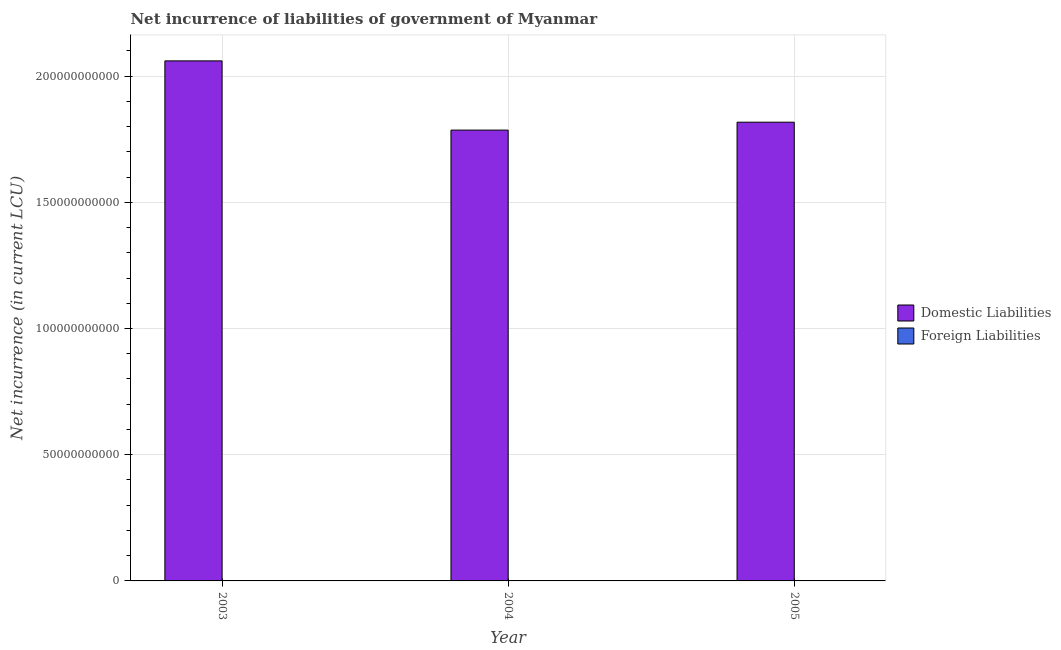Are the number of bars per tick equal to the number of legend labels?
Give a very brief answer. No. How many bars are there on the 2nd tick from the left?
Offer a terse response. 1. How many bars are there on the 1st tick from the right?
Offer a terse response. 1. What is the label of the 3rd group of bars from the left?
Your response must be concise. 2005. What is the net incurrence of domestic liabilities in 2004?
Offer a terse response. 1.79e+11. Across all years, what is the maximum net incurrence of domestic liabilities?
Keep it short and to the point. 2.06e+11. Across all years, what is the minimum net incurrence of foreign liabilities?
Ensure brevity in your answer.  0. In which year was the net incurrence of domestic liabilities maximum?
Your response must be concise. 2003. What is the total net incurrence of domestic liabilities in the graph?
Offer a terse response. 5.66e+11. What is the difference between the net incurrence of domestic liabilities in 2003 and that in 2005?
Give a very brief answer. 2.43e+1. What is the difference between the net incurrence of domestic liabilities in 2003 and the net incurrence of foreign liabilities in 2005?
Provide a succinct answer. 2.43e+1. What is the average net incurrence of domestic liabilities per year?
Offer a terse response. 1.89e+11. In the year 2004, what is the difference between the net incurrence of domestic liabilities and net incurrence of foreign liabilities?
Offer a very short reply. 0. What is the ratio of the net incurrence of domestic liabilities in 2003 to that in 2004?
Your answer should be compact. 1.15. What is the difference between the highest and the second highest net incurrence of domestic liabilities?
Provide a succinct answer. 2.43e+1. What is the difference between the highest and the lowest net incurrence of domestic liabilities?
Provide a short and direct response. 2.74e+1. Is the sum of the net incurrence of domestic liabilities in 2004 and 2005 greater than the maximum net incurrence of foreign liabilities across all years?
Provide a short and direct response. Yes. How many bars are there?
Your response must be concise. 3. Are all the bars in the graph horizontal?
Your answer should be compact. No. Are the values on the major ticks of Y-axis written in scientific E-notation?
Give a very brief answer. No. Does the graph contain any zero values?
Provide a short and direct response. Yes. Does the graph contain grids?
Your response must be concise. Yes. What is the title of the graph?
Your answer should be very brief. Net incurrence of liabilities of government of Myanmar. Does "Subsidies" appear as one of the legend labels in the graph?
Offer a very short reply. No. What is the label or title of the Y-axis?
Give a very brief answer. Net incurrence (in current LCU). What is the Net incurrence (in current LCU) in Domestic Liabilities in 2003?
Make the answer very short. 2.06e+11. What is the Net incurrence (in current LCU) of Domestic Liabilities in 2004?
Keep it short and to the point. 1.79e+11. What is the Net incurrence (in current LCU) of Domestic Liabilities in 2005?
Provide a succinct answer. 1.82e+11. Across all years, what is the maximum Net incurrence (in current LCU) in Domestic Liabilities?
Make the answer very short. 2.06e+11. Across all years, what is the minimum Net incurrence (in current LCU) of Domestic Liabilities?
Offer a very short reply. 1.79e+11. What is the total Net incurrence (in current LCU) of Domestic Liabilities in the graph?
Your answer should be compact. 5.66e+11. What is the total Net incurrence (in current LCU) of Foreign Liabilities in the graph?
Provide a succinct answer. 0. What is the difference between the Net incurrence (in current LCU) of Domestic Liabilities in 2003 and that in 2004?
Provide a succinct answer. 2.74e+1. What is the difference between the Net incurrence (in current LCU) of Domestic Liabilities in 2003 and that in 2005?
Your answer should be very brief. 2.43e+1. What is the difference between the Net incurrence (in current LCU) of Domestic Liabilities in 2004 and that in 2005?
Provide a succinct answer. -3.13e+09. What is the average Net incurrence (in current LCU) in Domestic Liabilities per year?
Make the answer very short. 1.89e+11. What is the average Net incurrence (in current LCU) in Foreign Liabilities per year?
Give a very brief answer. 0. What is the ratio of the Net incurrence (in current LCU) of Domestic Liabilities in 2003 to that in 2004?
Provide a succinct answer. 1.15. What is the ratio of the Net incurrence (in current LCU) of Domestic Liabilities in 2003 to that in 2005?
Your answer should be very brief. 1.13. What is the ratio of the Net incurrence (in current LCU) in Domestic Liabilities in 2004 to that in 2005?
Make the answer very short. 0.98. What is the difference between the highest and the second highest Net incurrence (in current LCU) of Domestic Liabilities?
Make the answer very short. 2.43e+1. What is the difference between the highest and the lowest Net incurrence (in current LCU) of Domestic Liabilities?
Provide a succinct answer. 2.74e+1. 